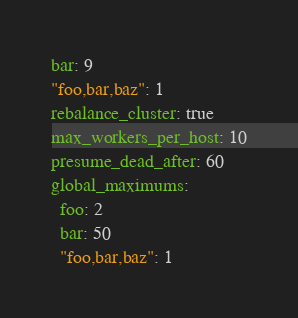Convert code to text. <code><loc_0><loc_0><loc_500><loc_500><_YAML_>bar: 9
"foo,bar,baz": 1
rebalance_cluster: true
max_workers_per_host: 10
presume_dead_after: 60
global_maximums:
  foo: 2
  bar: 50
  "foo,bar,baz": 1
</code> 